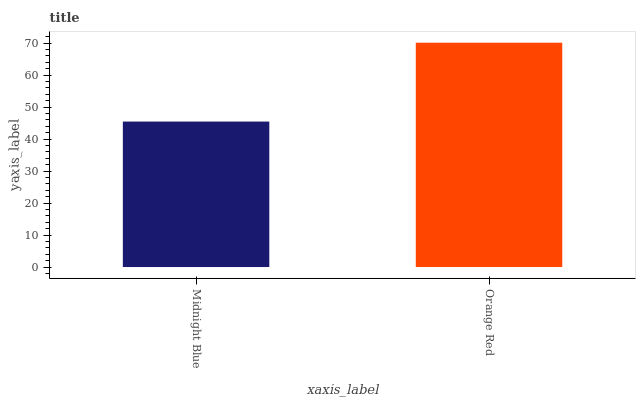Is Midnight Blue the minimum?
Answer yes or no. Yes. Is Orange Red the maximum?
Answer yes or no. Yes. Is Orange Red the minimum?
Answer yes or no. No. Is Orange Red greater than Midnight Blue?
Answer yes or no. Yes. Is Midnight Blue less than Orange Red?
Answer yes or no. Yes. Is Midnight Blue greater than Orange Red?
Answer yes or no. No. Is Orange Red less than Midnight Blue?
Answer yes or no. No. Is Orange Red the high median?
Answer yes or no. Yes. Is Midnight Blue the low median?
Answer yes or no. Yes. Is Midnight Blue the high median?
Answer yes or no. No. Is Orange Red the low median?
Answer yes or no. No. 